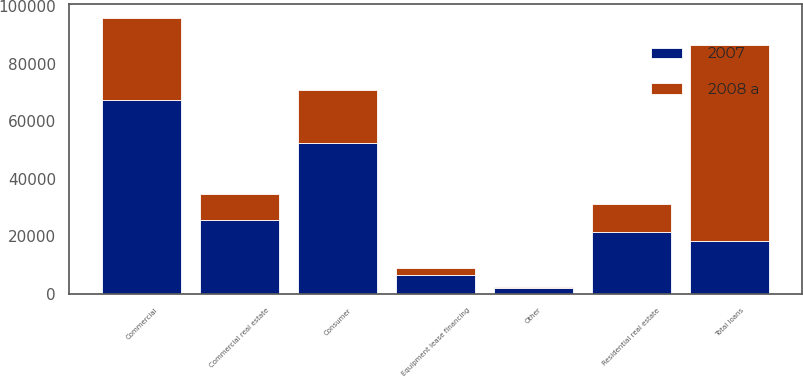<chart> <loc_0><loc_0><loc_500><loc_500><stacked_bar_chart><ecel><fcel>Commercial<fcel>Commercial real estate<fcel>Consumer<fcel>Residential real estate<fcel>Equipment lease financing<fcel>Other<fcel>Total loans<nl><fcel>2007<fcel>67319<fcel>25736<fcel>52489<fcel>21583<fcel>6461<fcel>1901<fcel>18393<nl><fcel>2008 a<fcel>28539<fcel>8903<fcel>18393<fcel>9557<fcel>2514<fcel>413<fcel>68319<nl></chart> 